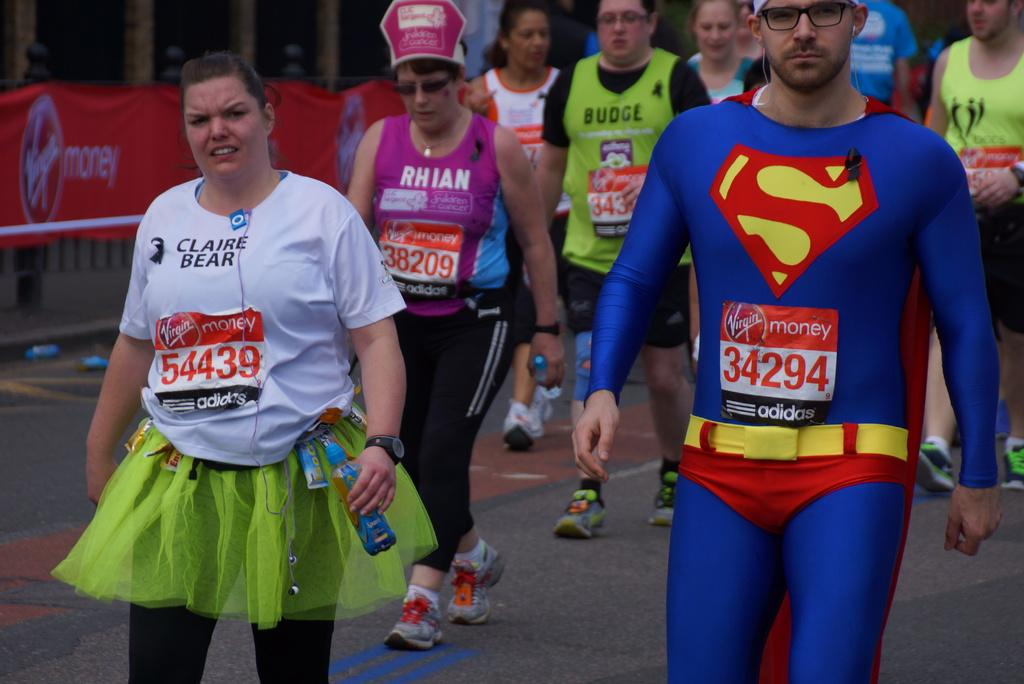Who or what can be seen in the image? There are people in the image. What are the people wearing? The people are wearing costumes. What are the people doing in the image? The people are walking on a road. What can be seen in the background of the image? There is a banner in the background of the image. What is written on the banner? There is text on the banner. What scent can be detected from the people in the image? There is no information about the scent of the people in the image, as it is not a visual detail. 